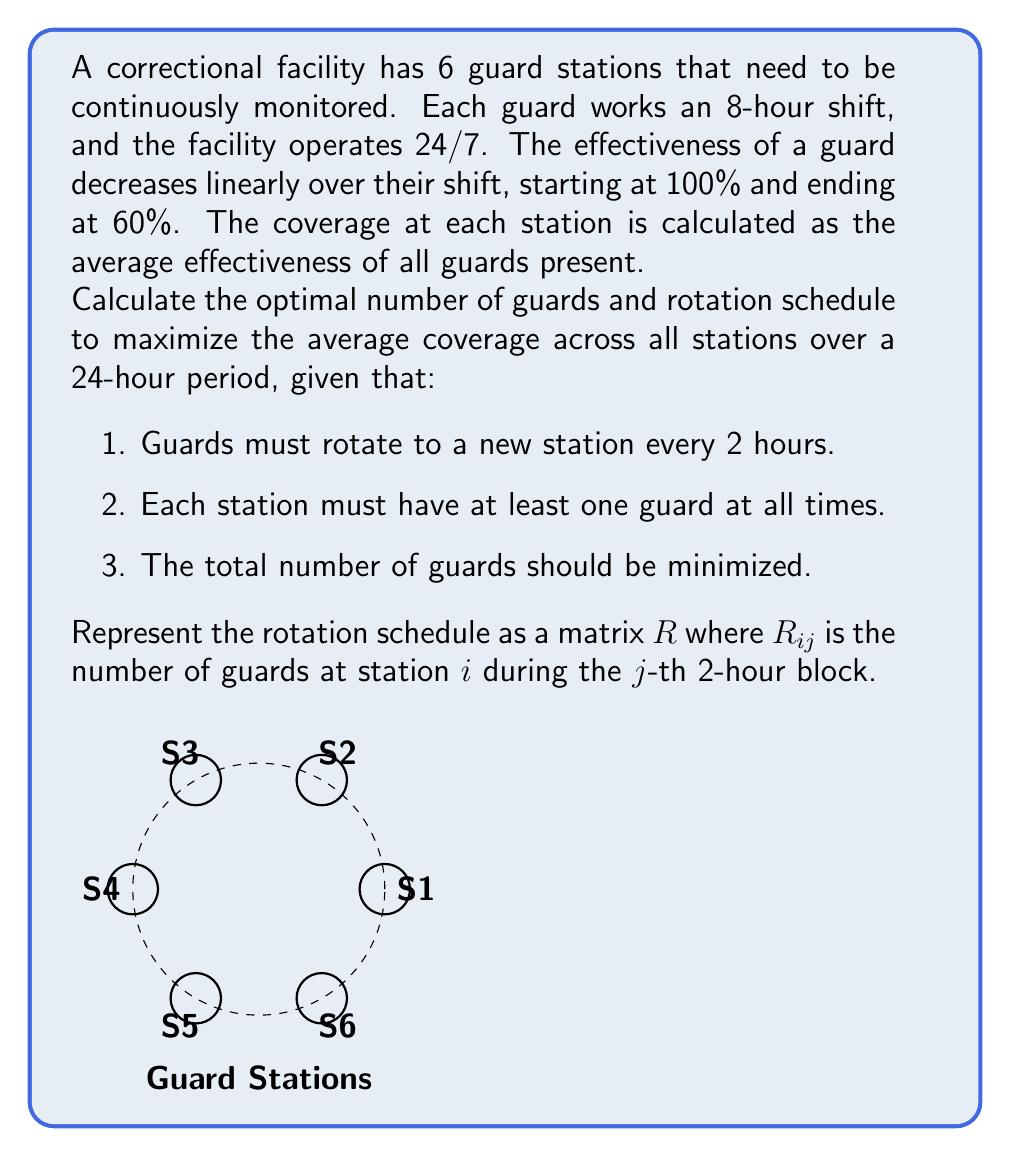Could you help me with this problem? Let's approach this problem step-by-step:

1) First, we need to determine the number of guards required. Since there are 6 stations and each must be covered at all times, we need at least 6 guards per shift. With 3 shifts in 24 hours, the minimum number of guards is 18.

2) The effectiveness of a guard over an 8-hour shift decreases linearly from 100% to 60%. We can model this as:

   $E(t) = 1 - 0.05t$, where $t$ is the number of hours worked (0 ≤ t ≤ 8).

3) To maximize coverage, we want to distribute the guards so that their average effectiveness is as high as possible at each station.

4) With 18 guards and 6 stations, we can have 3 guards per station on average. Let's rotate them every 2 hours as required.

5) The optimal rotation schedule will have each guard spending 2 hours at each of the 4 stations during their 8-hour shift. This way, no guard spends more than 2 hours at any station, ensuring a high average effectiveness.

6) The rotation matrix $R$ will be a 6x12 matrix (6 stations, 12 2-hour blocks in 24 hours). Each column should sum to 18 (total guards), and each row should have a sum divisible by 24 (equal coverage over 24 hours).

7) An optimal rotation schedule is:

   $$R = \begin{bmatrix}
   3 & 3 & 3 & 3 & 3 & 3 & 3 & 3 & 3 & 3 & 3 & 3 \\
   3 & 3 & 3 & 3 & 3 & 3 & 3 & 3 & 3 & 3 & 3 & 3 \\
   3 & 3 & 3 & 3 & 3 & 3 & 3 & 3 & 3 & 3 & 3 & 3 \\
   3 & 3 & 3 & 3 & 3 & 3 & 3 & 3 & 3 & 3 & 3 & 3 \\
   3 & 3 & 3 & 3 & 3 & 3 & 3 & 3 & 3 & 3 & 3 & 3 \\
   3 & 3 & 3 & 3 & 3 & 3 & 3 & 3 & 3 & 3 & 3 & 3
   \end{bmatrix}$$

8) The average effectiveness for each 2-hour block is:

   $E_{avg} = \frac{1}{3}(E(0) + E(2) + E(4)) = \frac{1}{3}(1 + 0.9 + 0.8) = 0.9$ or 90%

9) This average effectiveness is maintained throughout the 24-hour period at all stations.

Therefore, the optimal number of guards is 18, and the rotation schedule is represented by the matrix $R$ above, resulting in an average coverage of 90% across all stations over the 24-hour period.
Answer: 18 guards; Rotation matrix $R$ with 3 guards per station per 2-hour block; 90% average coverage 